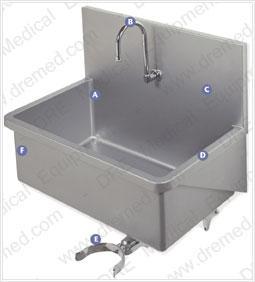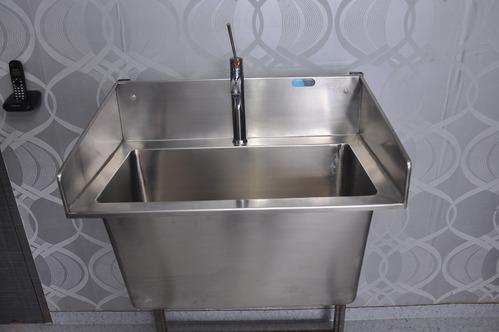The first image is the image on the left, the second image is the image on the right. Assess this claim about the two images: "Each image shows a steel sink with an undivided rectangular basin, but the sink on the right has a longer 'bin' under it.". Correct or not? Answer yes or no. Yes. The first image is the image on the left, the second image is the image on the right. For the images displayed, is the sentence "There is exactly one faucet in the left image." factually correct? Answer yes or no. Yes. 